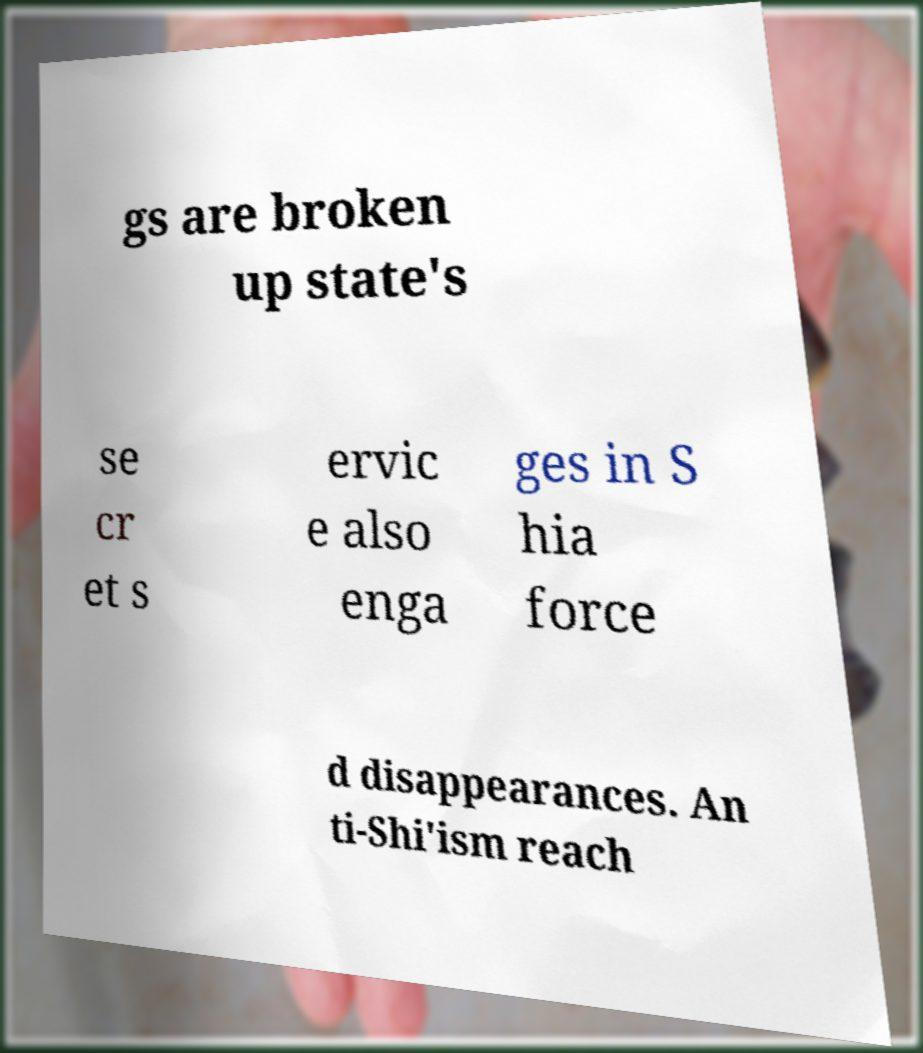There's text embedded in this image that I need extracted. Can you transcribe it verbatim? gs are broken up state's se cr et s ervic e also enga ges in S hia force d disappearances. An ti-Shi'ism reach 